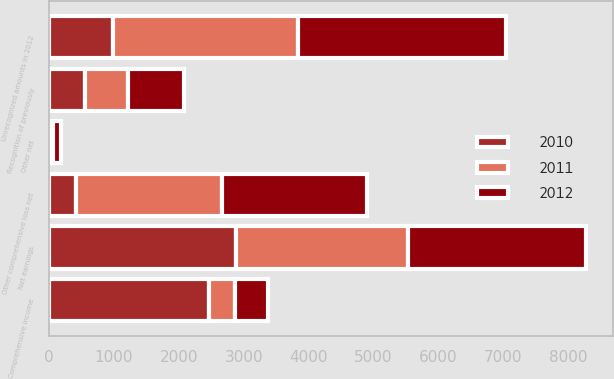<chart> <loc_0><loc_0><loc_500><loc_500><stacked_bar_chart><ecel><fcel>Net earnings<fcel>Unrecognized amounts in 2012<fcel>Recognition of previously<fcel>Other net<fcel>Other comprehensive loss net<fcel>Comprehensive income<nl><fcel>2012<fcel>2745<fcel>3204<fcel>858<fcel>110<fcel>2236<fcel>509<nl><fcel>2011<fcel>2655<fcel>2858<fcel>666<fcel>55<fcel>2247<fcel>408<nl><fcel>2010<fcel>2878<fcel>983<fcel>553<fcel>15<fcel>415<fcel>2463<nl></chart> 